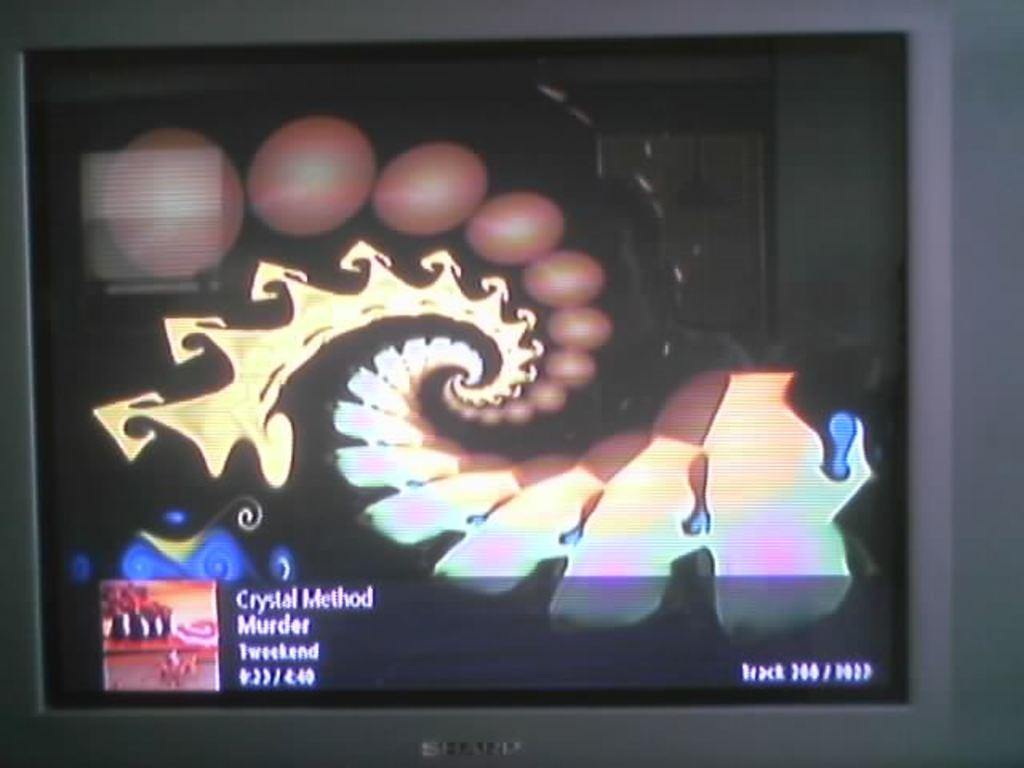<image>
Render a clear and concise summary of the photo. A monitor has a swirling picture and below it the words "Crystal Method" 